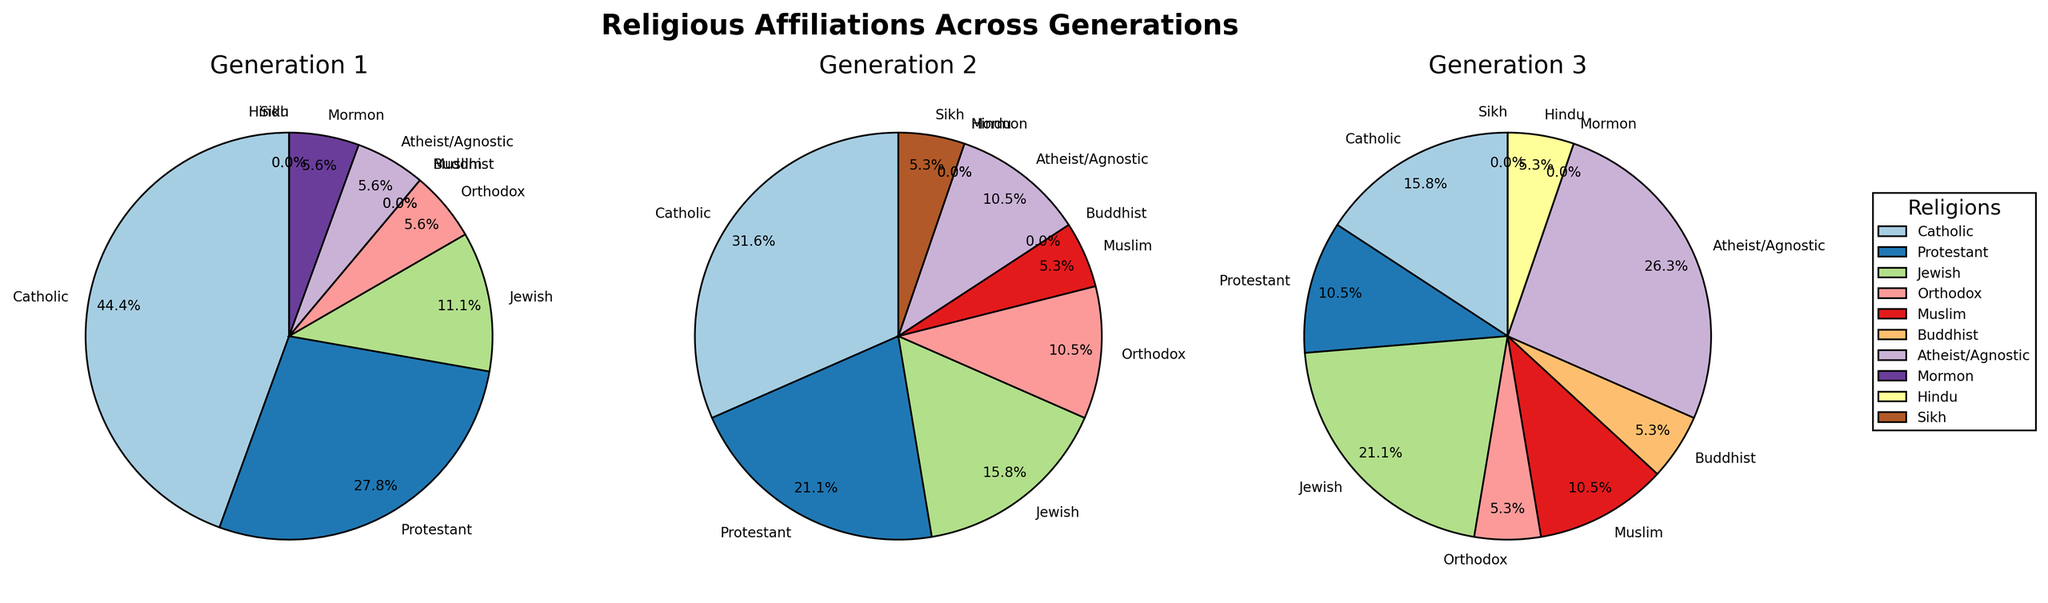Which religion has the highest number of members in Generation 1? To find the religion with the most members in Generation 1, we look at the data for Generation 1 and see that Catholic has 8 members, which is the highest value.
Answer: Catholic Which two religions have increased in membership from Generation 1 to Generation 3? Compare the number of members for each religion across Generation 1 and Generation 3. Jewish increased from 2 to 4, and Atheist/Agnostic increased from 1 to 5.
Answer: Jewish, Atheist/Agnostic What's the total number of family members in Generation 2? Add the number of members for all religions in Generation 2: 6 (Catholic) + 4 (Protestant) + 3 (Jewish) + 2 (Orthodox) + 1 (Muslim) + 2 (Atheist/Agnostic) + 1 (Sikh) = 19.
Answer: 19 Which generation has the highest proportion of Atheist/Agnostic members? Calculate the proportions of Atheist/Agnostic members in each generation: Gen 1 (1/17), Gen 2 (2/19), Gen 3 (5/19). Gen 3 has the highest proportion.
Answer: Generation 3 How does the number of Catholic members change from Generation 1 to Generation 3? Subtract the number of Catholic members in Generation 3 from those in Generation 1: 8 (Gen 1) - 3 (Gen 3) = 5 members decrease.
Answer: Decrease by 5 What is the sum of Jewish and Muslim members in Generation 3? Add the number of Jewish and Muslim members in Generation 3: 4 (Jewish) + 2 (Muslim) = 6.
Answer: 6 Which religion has the same number of members across Generation 1 and Generation 3? Compare the numbers for each religion in Generation 1 and Generation 3, and find that no religions have the same number of members.
Answer: None Which generation has the smallest representation of Protestant members, and what is their percentage in that generation? Look at the data for Protestant members across generations and calculate their percentages. Gen 3 has 2 members: (2/19) x 100 ≈ 10.5%.
Answer: Generation 3, 10.5% What is the decrease in the number of Protestant members from Generation 1 to Generation 3 as a percentage? Calculate the decrease first: 5 (Gen 1) - 2 (Gen 3) = 3. Then, find the percentage: (3/5) x 100 = 60%.
Answer: 60% Which religion first appears in Generation 3? Identify religions that have zero members in both Generation 1 and 2, but positive in Generation 3. Buddhist and Hindu both appear in Generation 3 only.
Answer: Buddhist, Hindu 